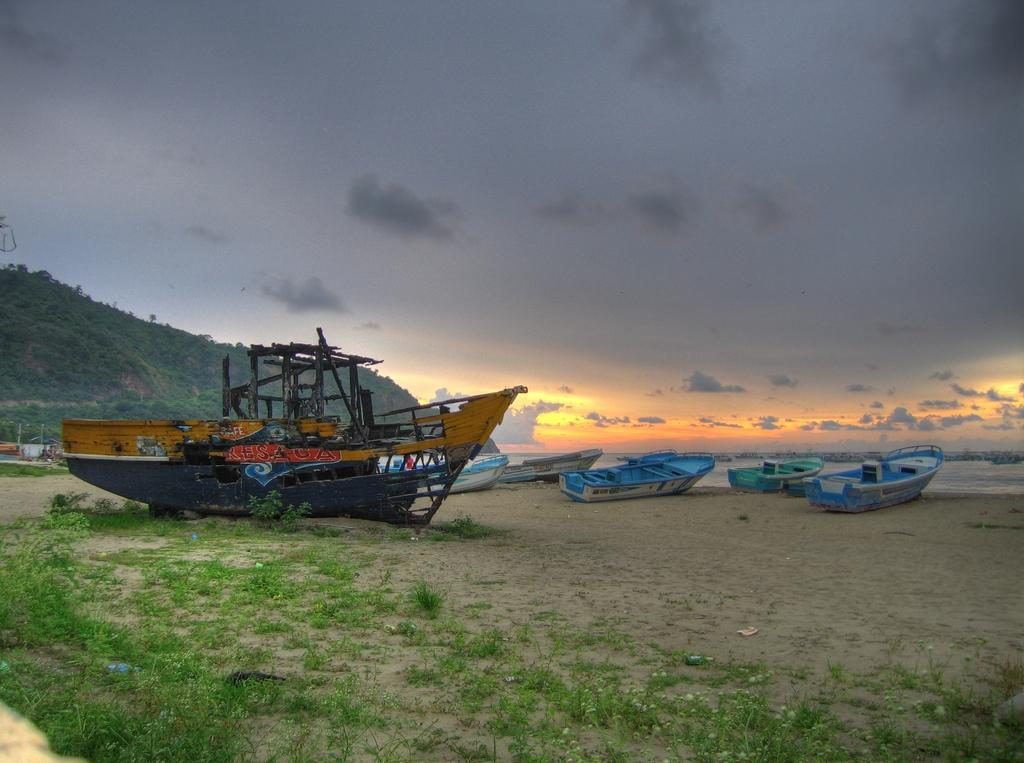What type of vegetation is present in the image? There is grass in the image. What objects can be seen floating on the water in the image? There are boats in the image. What can be seen in the distance in the background of the image? There is a hill and trees in the background of the image. What else is visible in the background of the image? There is water and the sky visible in the background of the image. Where are the dolls and beds located in the image? There are no dolls or beds present in the image. Can you tell me the color of the kitty in the image? There is no kitty present in the image. 